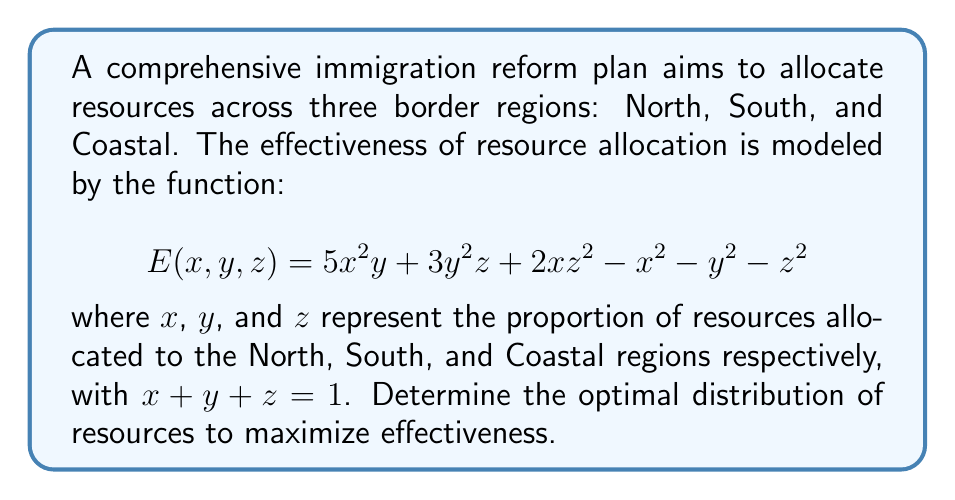Help me with this question. To find the optimal distribution of resources, we need to maximize the effectiveness function $E(x, y, z)$ subject to the constraint $x + y + z = 1$. We can use the method of Lagrange multipliers:

1) Form the Lagrangian function:
   $$L(x, y, z, \lambda) = 5x^2y + 3y^2z + 2xz^2 - x^2 - y^2 - z^2 - \lambda(x + y + z - 1)$$

2) Calculate partial derivatives and set them equal to zero:
   $$\frac{\partial L}{\partial x} = 10xy + 2z^2 - 2x - \lambda = 0$$
   $$\frac{\partial L}{\partial y} = 5x^2 + 6yz - 2y - \lambda = 0$$
   $$\frac{\partial L}{\partial z} = 3y^2 + 4xz - 2z - \lambda = 0$$
   $$\frac{\partial L}{\partial \lambda} = x + y + z - 1 = 0$$

3) Solve the system of equations:
   From the symmetry of the problem and the constraint, we can guess that the optimal solution might have equal allocation: $x = y = z = \frac{1}{3}$

4) Verify the solution:
   Substituting $x = y = z = \frac{1}{3}$ into the partial derivative equations:
   $$10(\frac{1}{3})(\frac{1}{3}) + 2(\frac{1}{3})^2 - 2(\frac{1}{3}) - \lambda = \frac{10}{9} + \frac{2}{9} - \frac{2}{3} - \lambda = \frac{4}{9} - \lambda = 0$$
   $$5(\frac{1}{3})^2 + 6(\frac{1}{3})(\frac{1}{3}) - 2(\frac{1}{3}) - \lambda = \frac{5}{9} + \frac{2}{3} - \frac{2}{3} - \lambda = \frac{5}{9} - \lambda = 0$$
   $$3(\frac{1}{3})^2 + 4(\frac{1}{3})(\frac{1}{3}) - 2(\frac{1}{3}) - \lambda = \frac{1}{3} + \frac{4}{9} - \frac{2}{3} - \lambda = \frac{1}{9} - \lambda = 0$$

   These equations are consistent, with $\lambda = \frac{4}{9}$, confirming our solution.

5) Verify it's a maximum:
   The second partial derivatives are all negative when evaluated at this point, confirming it's a local maximum.

Therefore, the optimal distribution is an equal allocation of resources across all three regions.
Answer: $x = y = z = \frac{1}{3}$ 